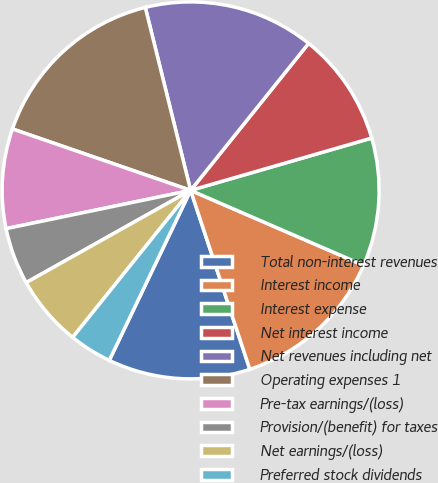<chart> <loc_0><loc_0><loc_500><loc_500><pie_chart><fcel>Total non-interest revenues<fcel>Interest income<fcel>Interest expense<fcel>Net interest income<fcel>Net revenues including net<fcel>Operating expenses 1<fcel>Pre-tax earnings/(loss)<fcel>Provision/(benefit) for taxes<fcel>Net earnings/(loss)<fcel>Preferred stock dividends<nl><fcel>12.19%<fcel>13.41%<fcel>10.98%<fcel>9.76%<fcel>14.63%<fcel>15.85%<fcel>8.54%<fcel>4.88%<fcel>6.1%<fcel>3.66%<nl></chart> 